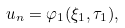<formula> <loc_0><loc_0><loc_500><loc_500>u _ { n } = \varphi _ { 1 } ( \xi _ { 1 } , \tau _ { 1 } ) ,</formula> 